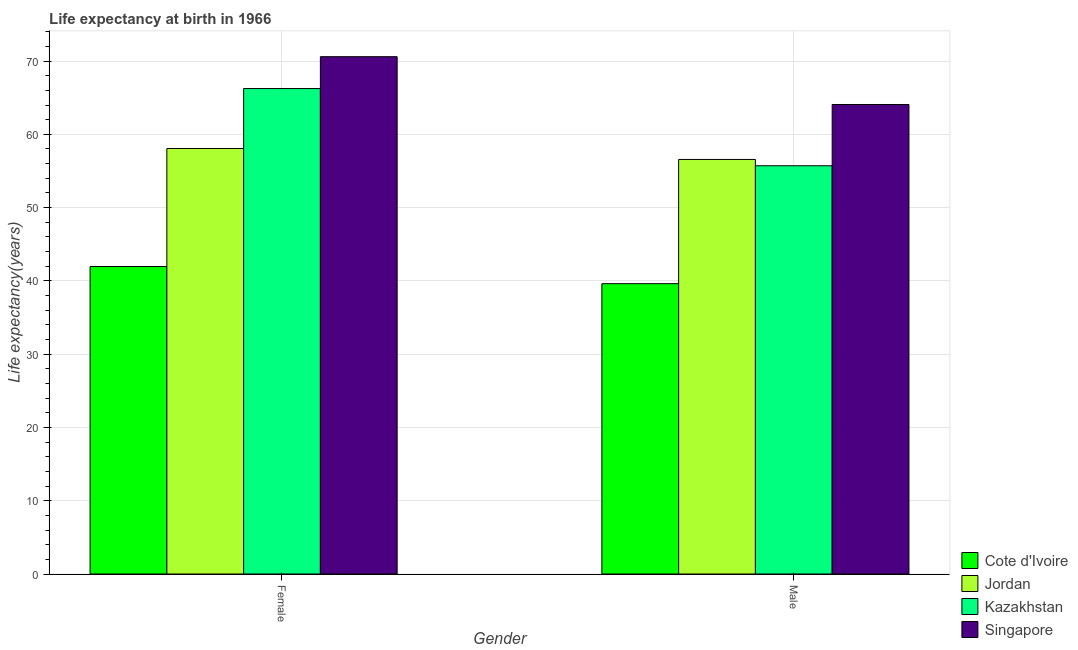How many different coloured bars are there?
Give a very brief answer. 4. How many groups of bars are there?
Ensure brevity in your answer.  2. Are the number of bars on each tick of the X-axis equal?
Offer a very short reply. Yes. How many bars are there on the 2nd tick from the left?
Your answer should be compact. 4. How many bars are there on the 2nd tick from the right?
Your answer should be very brief. 4. What is the life expectancy(female) in Cote d'Ivoire?
Keep it short and to the point. 41.96. Across all countries, what is the maximum life expectancy(female)?
Keep it short and to the point. 70.6. Across all countries, what is the minimum life expectancy(male)?
Keep it short and to the point. 39.62. In which country was the life expectancy(female) maximum?
Offer a terse response. Singapore. In which country was the life expectancy(female) minimum?
Offer a very short reply. Cote d'Ivoire. What is the total life expectancy(male) in the graph?
Your answer should be very brief. 215.98. What is the difference between the life expectancy(female) in Cote d'Ivoire and that in Jordan?
Ensure brevity in your answer.  -16.11. What is the difference between the life expectancy(female) in Jordan and the life expectancy(male) in Cote d'Ivoire?
Provide a succinct answer. 18.45. What is the average life expectancy(female) per country?
Provide a succinct answer. 59.22. What is the difference between the life expectancy(female) and life expectancy(male) in Kazakhstan?
Provide a succinct answer. 10.54. What is the ratio of the life expectancy(female) in Cote d'Ivoire to that in Jordan?
Your answer should be very brief. 0.72. What does the 1st bar from the left in Male represents?
Offer a terse response. Cote d'Ivoire. What does the 1st bar from the right in Male represents?
Your answer should be compact. Singapore. How many bars are there?
Offer a very short reply. 8. How many countries are there in the graph?
Give a very brief answer. 4. How many legend labels are there?
Make the answer very short. 4. How are the legend labels stacked?
Make the answer very short. Vertical. What is the title of the graph?
Offer a terse response. Life expectancy at birth in 1966. What is the label or title of the Y-axis?
Your answer should be compact. Life expectancy(years). What is the Life expectancy(years) of Cote d'Ivoire in Female?
Provide a short and direct response. 41.96. What is the Life expectancy(years) in Jordan in Female?
Your response must be concise. 58.07. What is the Life expectancy(years) in Kazakhstan in Female?
Offer a very short reply. 66.25. What is the Life expectancy(years) in Singapore in Female?
Offer a very short reply. 70.6. What is the Life expectancy(years) in Cote d'Ivoire in Male?
Ensure brevity in your answer.  39.62. What is the Life expectancy(years) of Jordan in Male?
Provide a short and direct response. 56.57. What is the Life expectancy(years) of Kazakhstan in Male?
Ensure brevity in your answer.  55.71. What is the Life expectancy(years) of Singapore in Male?
Your answer should be very brief. 64.07. Across all Gender, what is the maximum Life expectancy(years) of Cote d'Ivoire?
Offer a terse response. 41.96. Across all Gender, what is the maximum Life expectancy(years) in Jordan?
Make the answer very short. 58.07. Across all Gender, what is the maximum Life expectancy(years) of Kazakhstan?
Offer a terse response. 66.25. Across all Gender, what is the maximum Life expectancy(years) of Singapore?
Provide a short and direct response. 70.6. Across all Gender, what is the minimum Life expectancy(years) of Cote d'Ivoire?
Make the answer very short. 39.62. Across all Gender, what is the minimum Life expectancy(years) in Jordan?
Make the answer very short. 56.57. Across all Gender, what is the minimum Life expectancy(years) in Kazakhstan?
Offer a very short reply. 55.71. Across all Gender, what is the minimum Life expectancy(years) of Singapore?
Give a very brief answer. 64.07. What is the total Life expectancy(years) in Cote d'Ivoire in the graph?
Offer a terse response. 81.58. What is the total Life expectancy(years) of Jordan in the graph?
Offer a terse response. 114.64. What is the total Life expectancy(years) in Kazakhstan in the graph?
Your answer should be very brief. 121.96. What is the total Life expectancy(years) in Singapore in the graph?
Provide a succinct answer. 134.67. What is the difference between the Life expectancy(years) in Cote d'Ivoire in Female and that in Male?
Provide a short and direct response. 2.34. What is the difference between the Life expectancy(years) of Jordan in Female and that in Male?
Keep it short and to the point. 1.5. What is the difference between the Life expectancy(years) of Kazakhstan in Female and that in Male?
Provide a succinct answer. 10.54. What is the difference between the Life expectancy(years) in Singapore in Female and that in Male?
Your answer should be very brief. 6.52. What is the difference between the Life expectancy(years) in Cote d'Ivoire in Female and the Life expectancy(years) in Jordan in Male?
Keep it short and to the point. -14.61. What is the difference between the Life expectancy(years) of Cote d'Ivoire in Female and the Life expectancy(years) of Kazakhstan in Male?
Your answer should be very brief. -13.75. What is the difference between the Life expectancy(years) of Cote d'Ivoire in Female and the Life expectancy(years) of Singapore in Male?
Make the answer very short. -22.11. What is the difference between the Life expectancy(years) of Jordan in Female and the Life expectancy(years) of Kazakhstan in Male?
Offer a very short reply. 2.36. What is the difference between the Life expectancy(years) in Jordan in Female and the Life expectancy(years) in Singapore in Male?
Ensure brevity in your answer.  -6. What is the difference between the Life expectancy(years) in Kazakhstan in Female and the Life expectancy(years) in Singapore in Male?
Keep it short and to the point. 2.17. What is the average Life expectancy(years) in Cote d'Ivoire per Gender?
Your response must be concise. 40.79. What is the average Life expectancy(years) of Jordan per Gender?
Offer a terse response. 57.32. What is the average Life expectancy(years) in Kazakhstan per Gender?
Your answer should be compact. 60.98. What is the average Life expectancy(years) in Singapore per Gender?
Keep it short and to the point. 67.34. What is the difference between the Life expectancy(years) of Cote d'Ivoire and Life expectancy(years) of Jordan in Female?
Offer a very short reply. -16.11. What is the difference between the Life expectancy(years) in Cote d'Ivoire and Life expectancy(years) in Kazakhstan in Female?
Your answer should be very brief. -24.29. What is the difference between the Life expectancy(years) of Cote d'Ivoire and Life expectancy(years) of Singapore in Female?
Your response must be concise. -28.64. What is the difference between the Life expectancy(years) in Jordan and Life expectancy(years) in Kazakhstan in Female?
Your answer should be compact. -8.18. What is the difference between the Life expectancy(years) in Jordan and Life expectancy(years) in Singapore in Female?
Keep it short and to the point. -12.53. What is the difference between the Life expectancy(years) in Kazakhstan and Life expectancy(years) in Singapore in Female?
Your answer should be compact. -4.35. What is the difference between the Life expectancy(years) in Cote d'Ivoire and Life expectancy(years) in Jordan in Male?
Make the answer very short. -16.95. What is the difference between the Life expectancy(years) of Cote d'Ivoire and Life expectancy(years) of Kazakhstan in Male?
Offer a terse response. -16.09. What is the difference between the Life expectancy(years) in Cote d'Ivoire and Life expectancy(years) in Singapore in Male?
Make the answer very short. -24.45. What is the difference between the Life expectancy(years) of Jordan and Life expectancy(years) of Kazakhstan in Male?
Make the answer very short. 0.86. What is the difference between the Life expectancy(years) in Jordan and Life expectancy(years) in Singapore in Male?
Keep it short and to the point. -7.5. What is the difference between the Life expectancy(years) in Kazakhstan and Life expectancy(years) in Singapore in Male?
Offer a terse response. -8.36. What is the ratio of the Life expectancy(years) in Cote d'Ivoire in Female to that in Male?
Provide a succinct answer. 1.06. What is the ratio of the Life expectancy(years) in Jordan in Female to that in Male?
Make the answer very short. 1.03. What is the ratio of the Life expectancy(years) of Kazakhstan in Female to that in Male?
Make the answer very short. 1.19. What is the ratio of the Life expectancy(years) of Singapore in Female to that in Male?
Your response must be concise. 1.1. What is the difference between the highest and the second highest Life expectancy(years) of Cote d'Ivoire?
Your response must be concise. 2.34. What is the difference between the highest and the second highest Life expectancy(years) of Jordan?
Offer a very short reply. 1.5. What is the difference between the highest and the second highest Life expectancy(years) of Kazakhstan?
Your answer should be very brief. 10.54. What is the difference between the highest and the second highest Life expectancy(years) of Singapore?
Your answer should be compact. 6.52. What is the difference between the highest and the lowest Life expectancy(years) of Cote d'Ivoire?
Keep it short and to the point. 2.34. What is the difference between the highest and the lowest Life expectancy(years) of Jordan?
Offer a very short reply. 1.5. What is the difference between the highest and the lowest Life expectancy(years) of Kazakhstan?
Give a very brief answer. 10.54. What is the difference between the highest and the lowest Life expectancy(years) in Singapore?
Give a very brief answer. 6.52. 